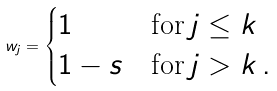Convert formula to latex. <formula><loc_0><loc_0><loc_500><loc_500>w _ { j } = \begin{cases} 1 & \text {for} \, j \leq k \\ 1 - s & \text {for} \, j > k \, . \end{cases}</formula> 